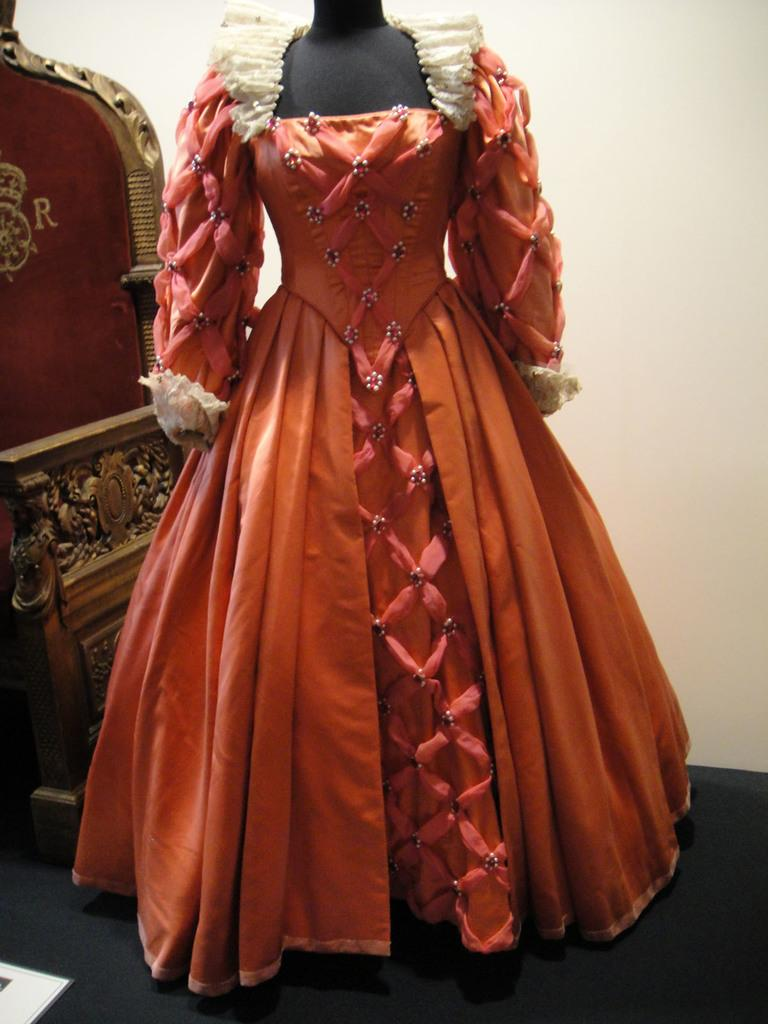What type of clothing is visible in the image? There is a dress in the image. What piece of furniture is present in the image? There is a chair placed on the ground in the image. On which side of the image is the chair located? The chair is on the left side of the image. What type of circle can be seen in the territory of the amusement park in the image? There is no circle, territory, or amusement park present in the image. 